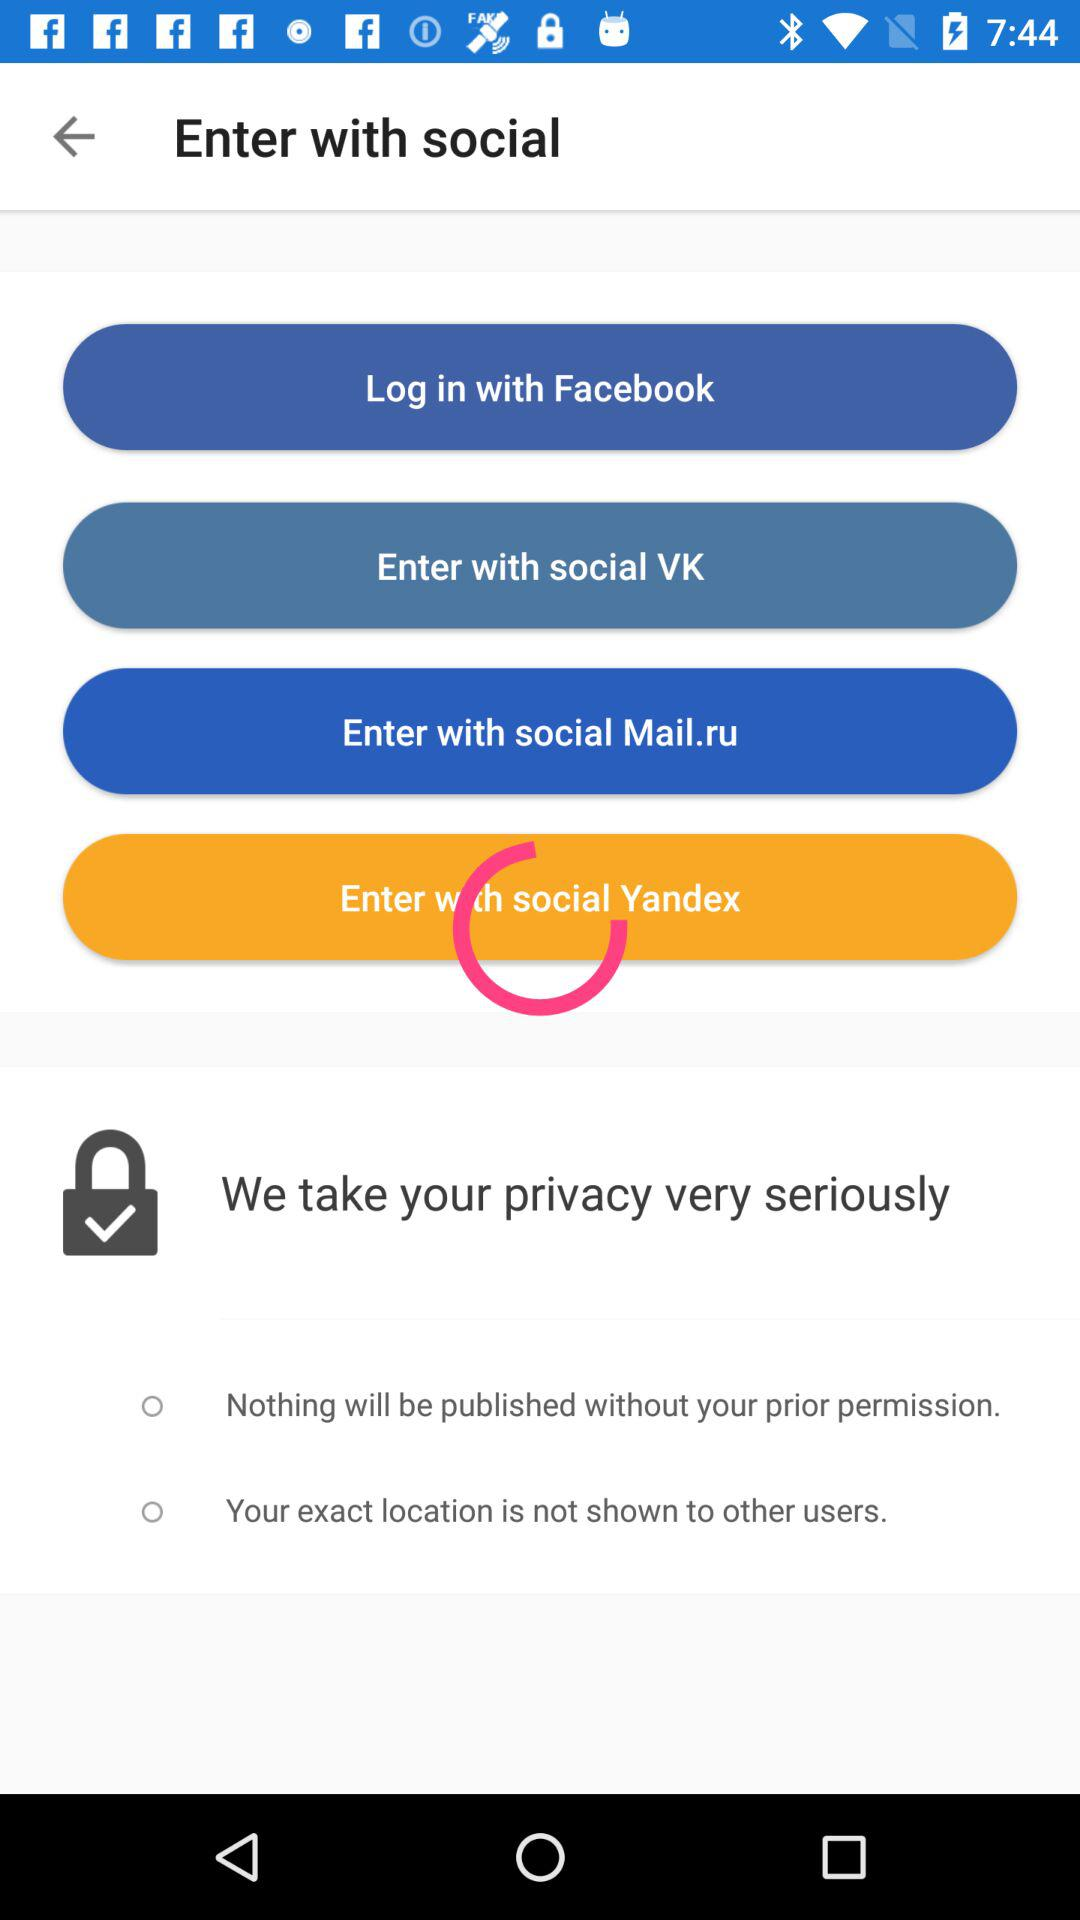What are the options available for privacy settings?
When the provided information is insufficient, respond with <no answer>. <no answer> 